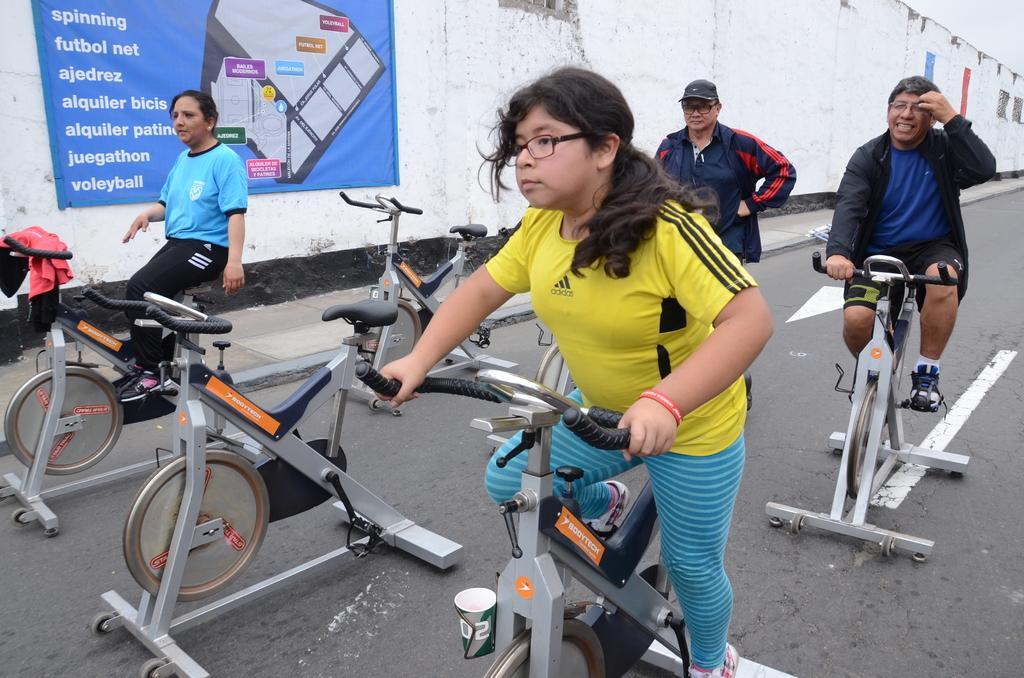Could you give a brief overview of what you see in this image? In this picture we can see there are three people riding the stationary bicycles and the stationary bicycles are on the road. Behind the three people, it looks like a person is standing. On the left side of the people there is a banner on the wall and on the stationary bicycle there is a jacket. 